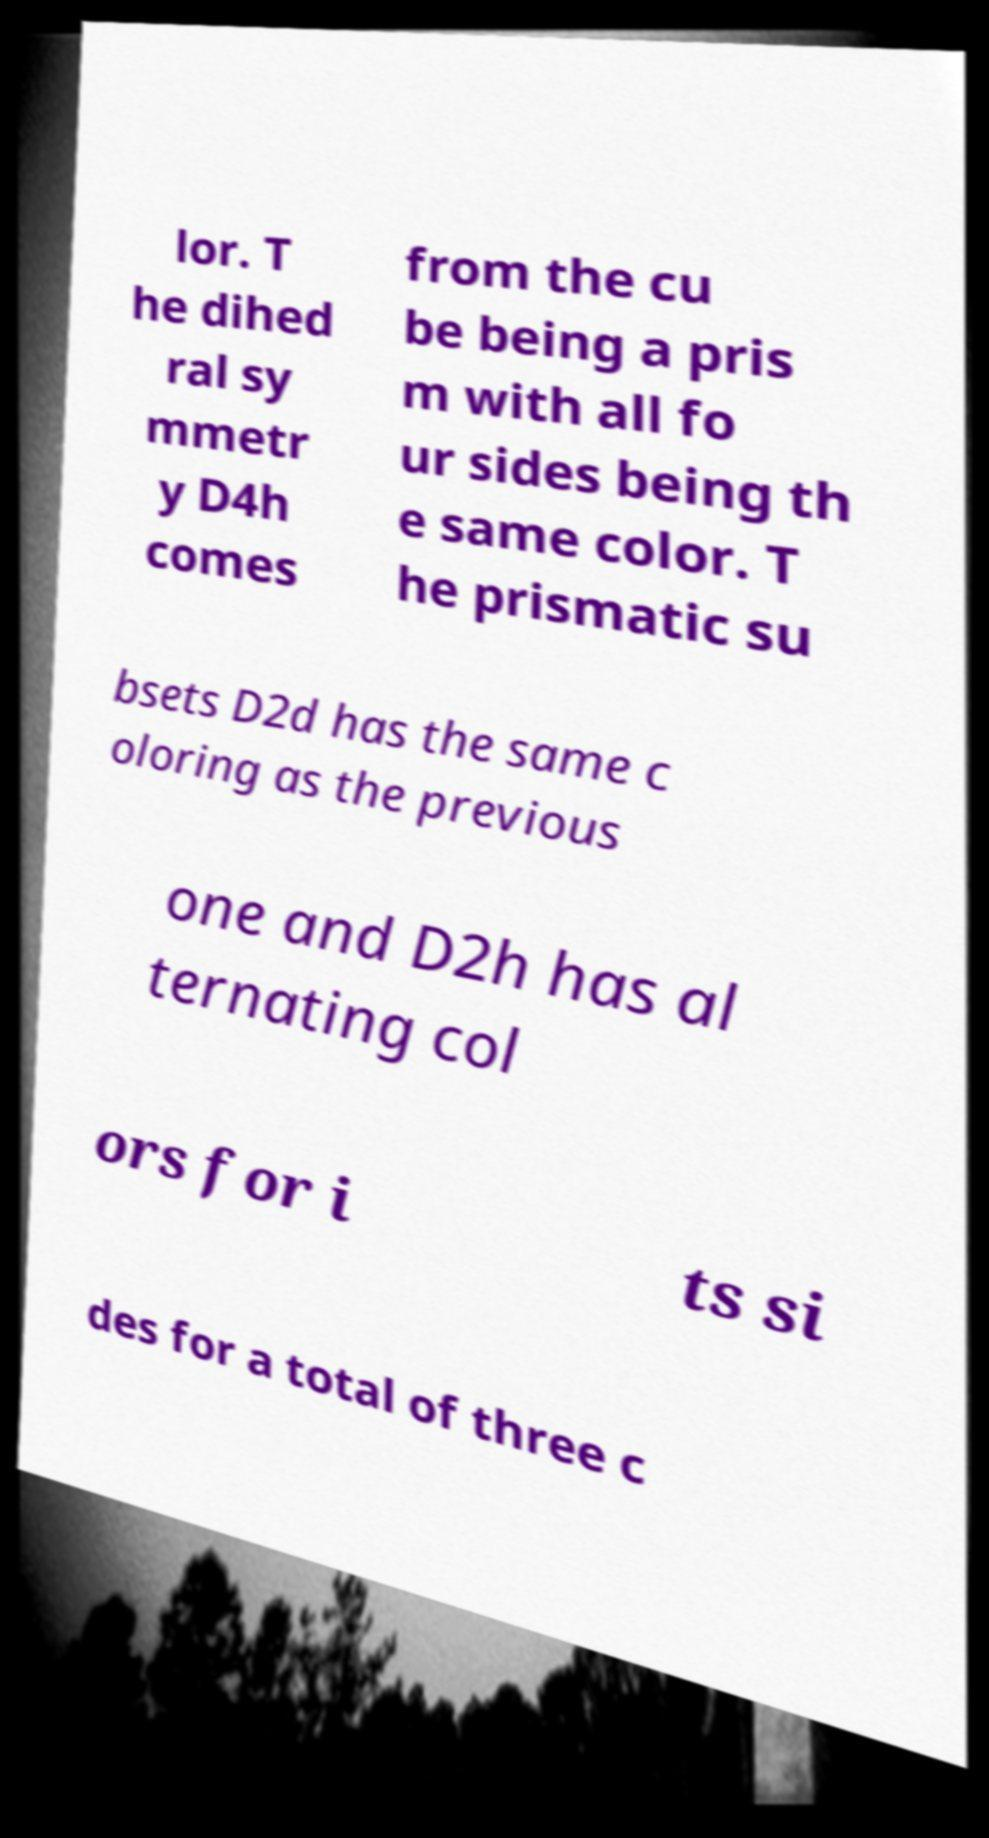For documentation purposes, I need the text within this image transcribed. Could you provide that? lor. T he dihed ral sy mmetr y D4h comes from the cu be being a pris m with all fo ur sides being th e same color. T he prismatic su bsets D2d has the same c oloring as the previous one and D2h has al ternating col ors for i ts si des for a total of three c 